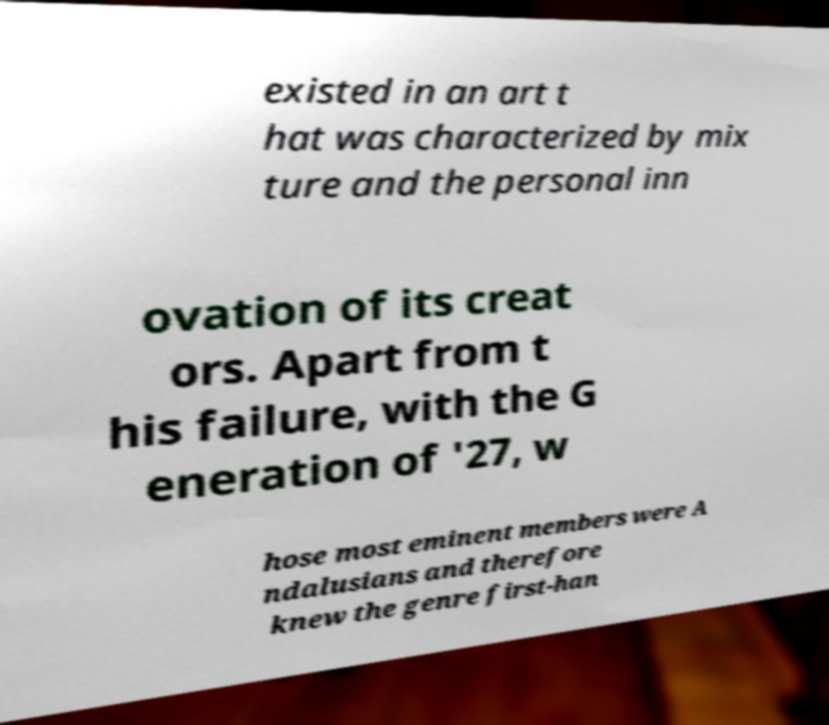There's text embedded in this image that I need extracted. Can you transcribe it verbatim? existed in an art t hat was characterized by mix ture and the personal inn ovation of its creat ors. Apart from t his failure, with the G eneration of '27, w hose most eminent members were A ndalusians and therefore knew the genre first-han 